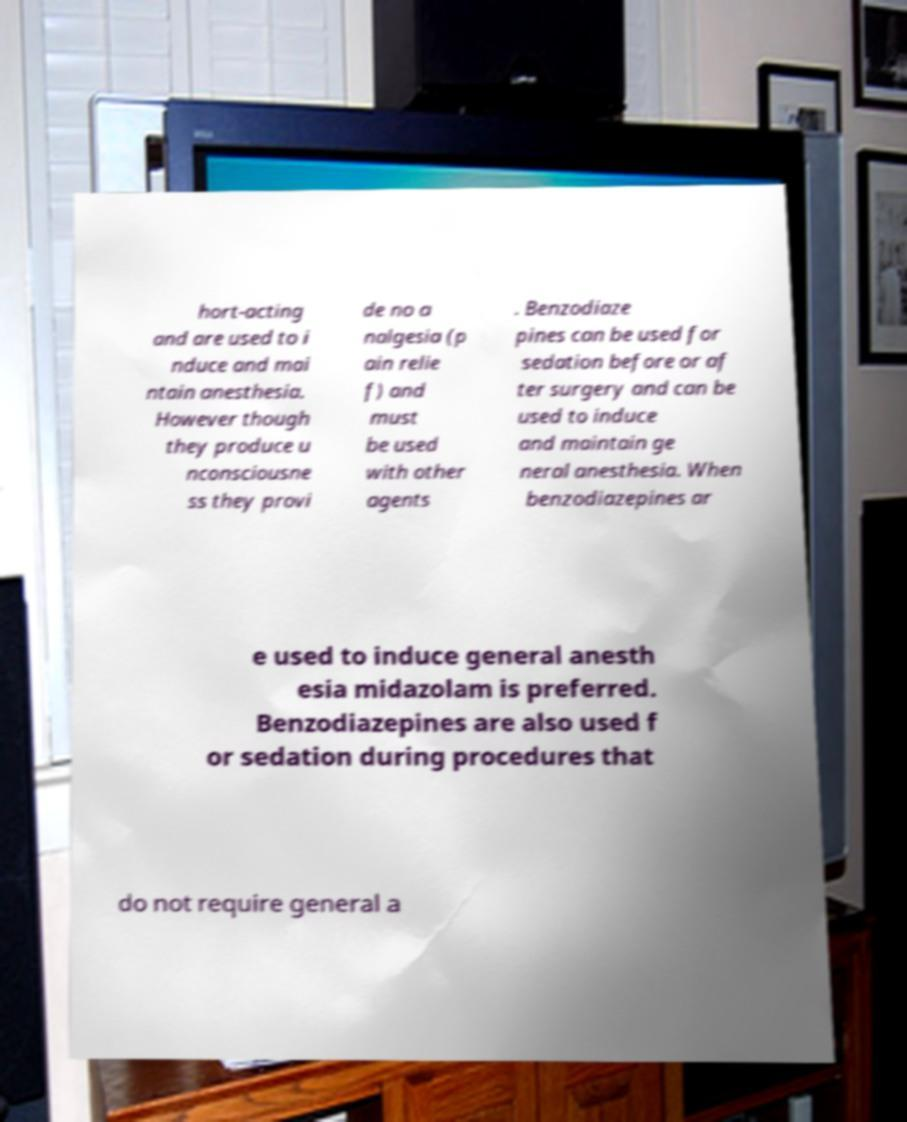Could you extract and type out the text from this image? hort-acting and are used to i nduce and mai ntain anesthesia. However though they produce u nconsciousne ss they provi de no a nalgesia (p ain relie f) and must be used with other agents . Benzodiaze pines can be used for sedation before or af ter surgery and can be used to induce and maintain ge neral anesthesia. When benzodiazepines ar e used to induce general anesth esia midazolam is preferred. Benzodiazepines are also used f or sedation during procedures that do not require general a 